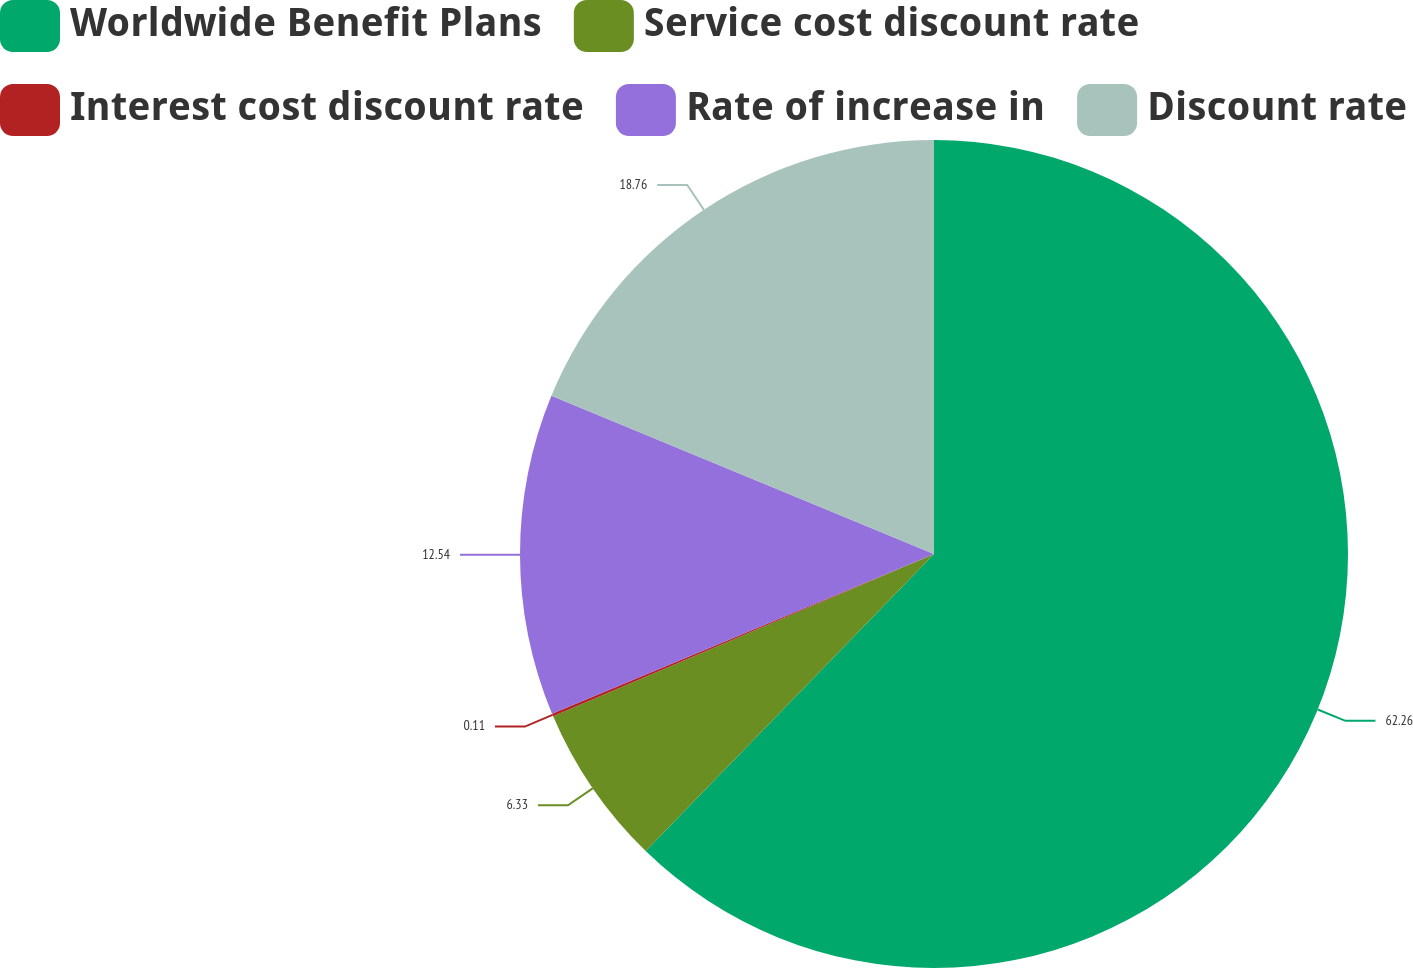<chart> <loc_0><loc_0><loc_500><loc_500><pie_chart><fcel>Worldwide Benefit Plans<fcel>Service cost discount rate<fcel>Interest cost discount rate<fcel>Rate of increase in<fcel>Discount rate<nl><fcel>62.26%<fcel>6.33%<fcel>0.11%<fcel>12.54%<fcel>18.76%<nl></chart> 